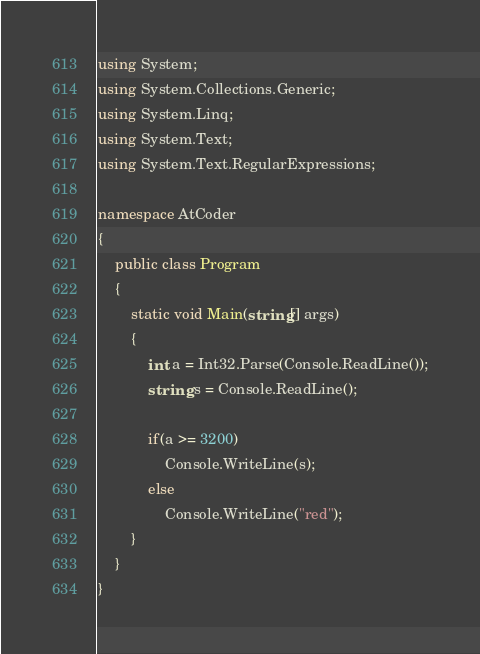Convert code to text. <code><loc_0><loc_0><loc_500><loc_500><_C#_>using System;
using System.Collections.Generic;
using System.Linq;
using System.Text;
using System.Text.RegularExpressions;

namespace AtCoder
{
	public class Program
	{
		static void Main(string[] args)
		{
			int a = Int32.Parse(Console.ReadLine());
			string s = Console.ReadLine();

			if(a >= 3200)
				Console.WriteLine(s);
			else
				Console.WriteLine("red");
		}
	}
}
</code> 